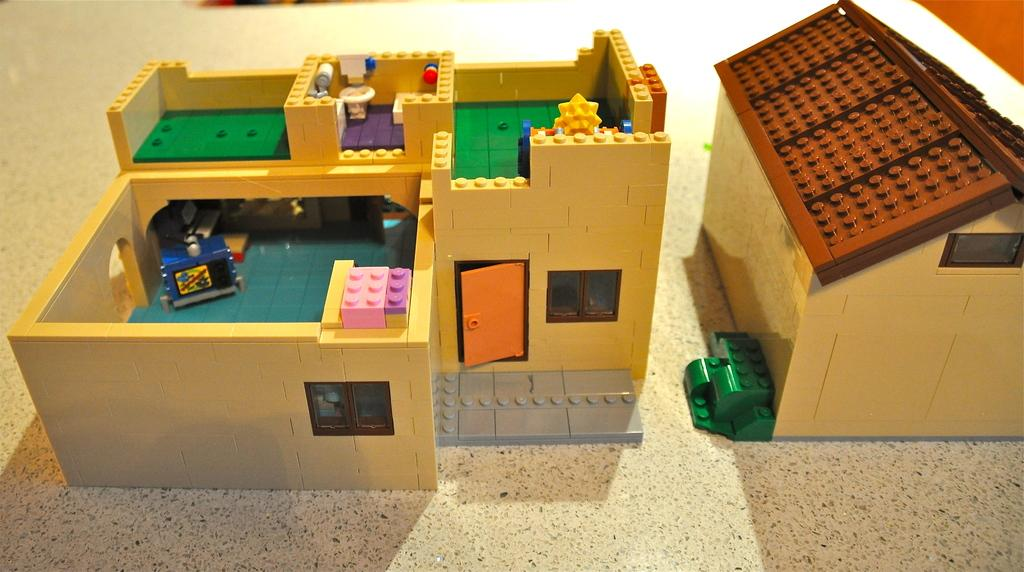How many houses are present in the image? There are two houses in the image. What are the houses made of? The houses are made of Lego. Are the houses the same color? No, the houses are in different colors. Can you describe any objects inside or on the houses? Yes, there are objects inside and on the surface of the houses. What type of toothpaste is being used to build the houses in the image? There is no toothpaste present in the image; the houses are made of Lego. How many pizzas are being served on the roof of the houses in the image? There are no pizzas present in the image; the objects on the houses are not specified. 